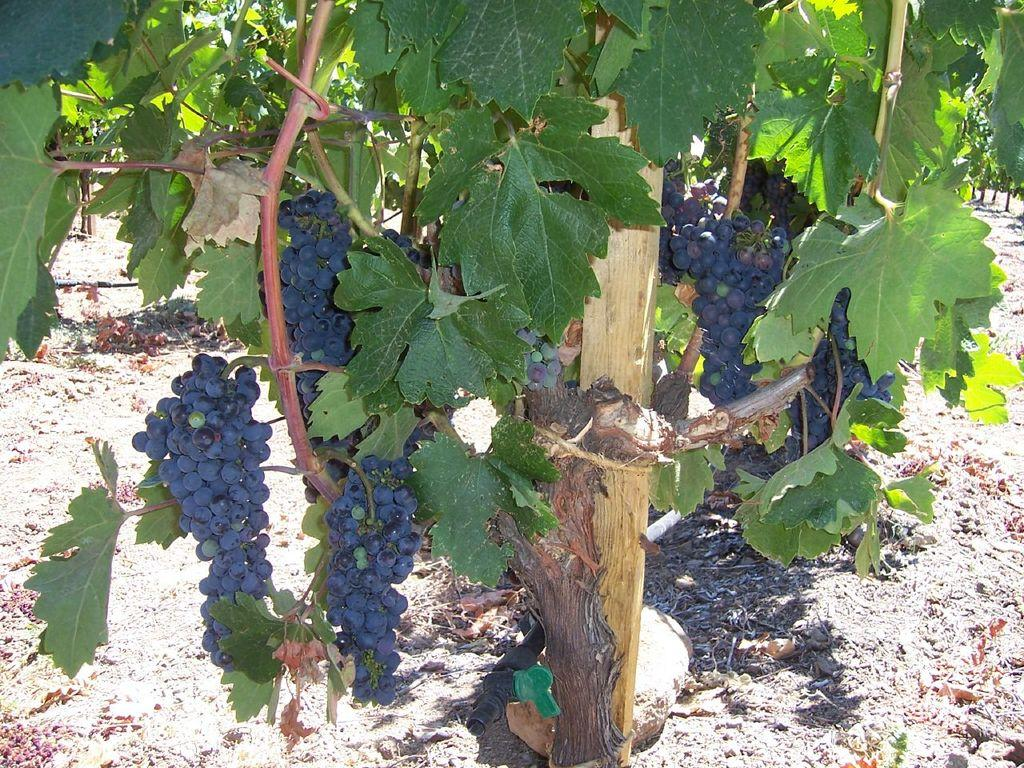What type of fruit is growing on the plant in the image? There are grapes on a grape plant in the image. What material is the pole made of in the image? The pole in the image is made of wood. What can be found on the ground in the image? Dried leaves are present on the ground in the image. What object is lying on the ground in the image? There is a pipe on the ground in the image. What type of silk is being used to tie the grape plant to the wooden pole in the image? There is no silk present in the image; the grape plant is not tied to the wooden pole. 